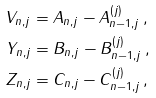Convert formula to latex. <formula><loc_0><loc_0><loc_500><loc_500>V _ { n , j } & = A _ { n , j } - A _ { n - 1 , j } ^ { ( j ) } \, , \\ Y _ { n , j } & = B _ { n , j } - B _ { n - 1 , j } ^ { ( j ) } \, , \\ Z _ { n , j } & = C _ { n , j } - C _ { n - 1 , j } ^ { ( j ) } \, ,</formula> 